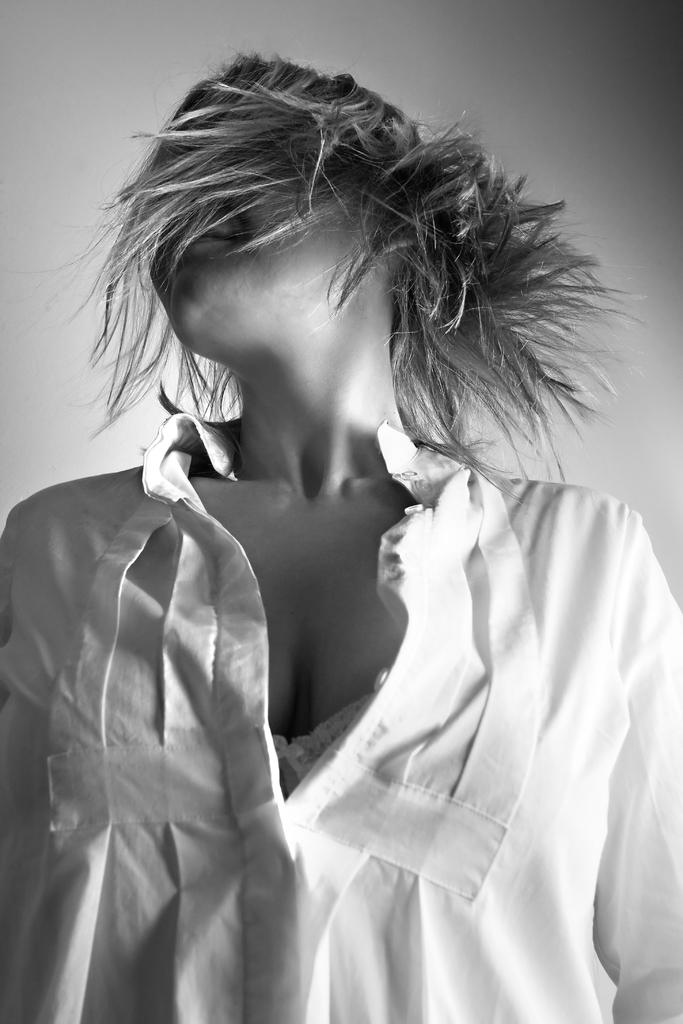What is the color scheme of the image? The image is black and white. Can you describe the main subject in the image? There is a woman in the image. What type of prose is the woman reading in the image? There is no indication in the image that the woman is reading any prose, as the image is black and white and only shows a woman. 